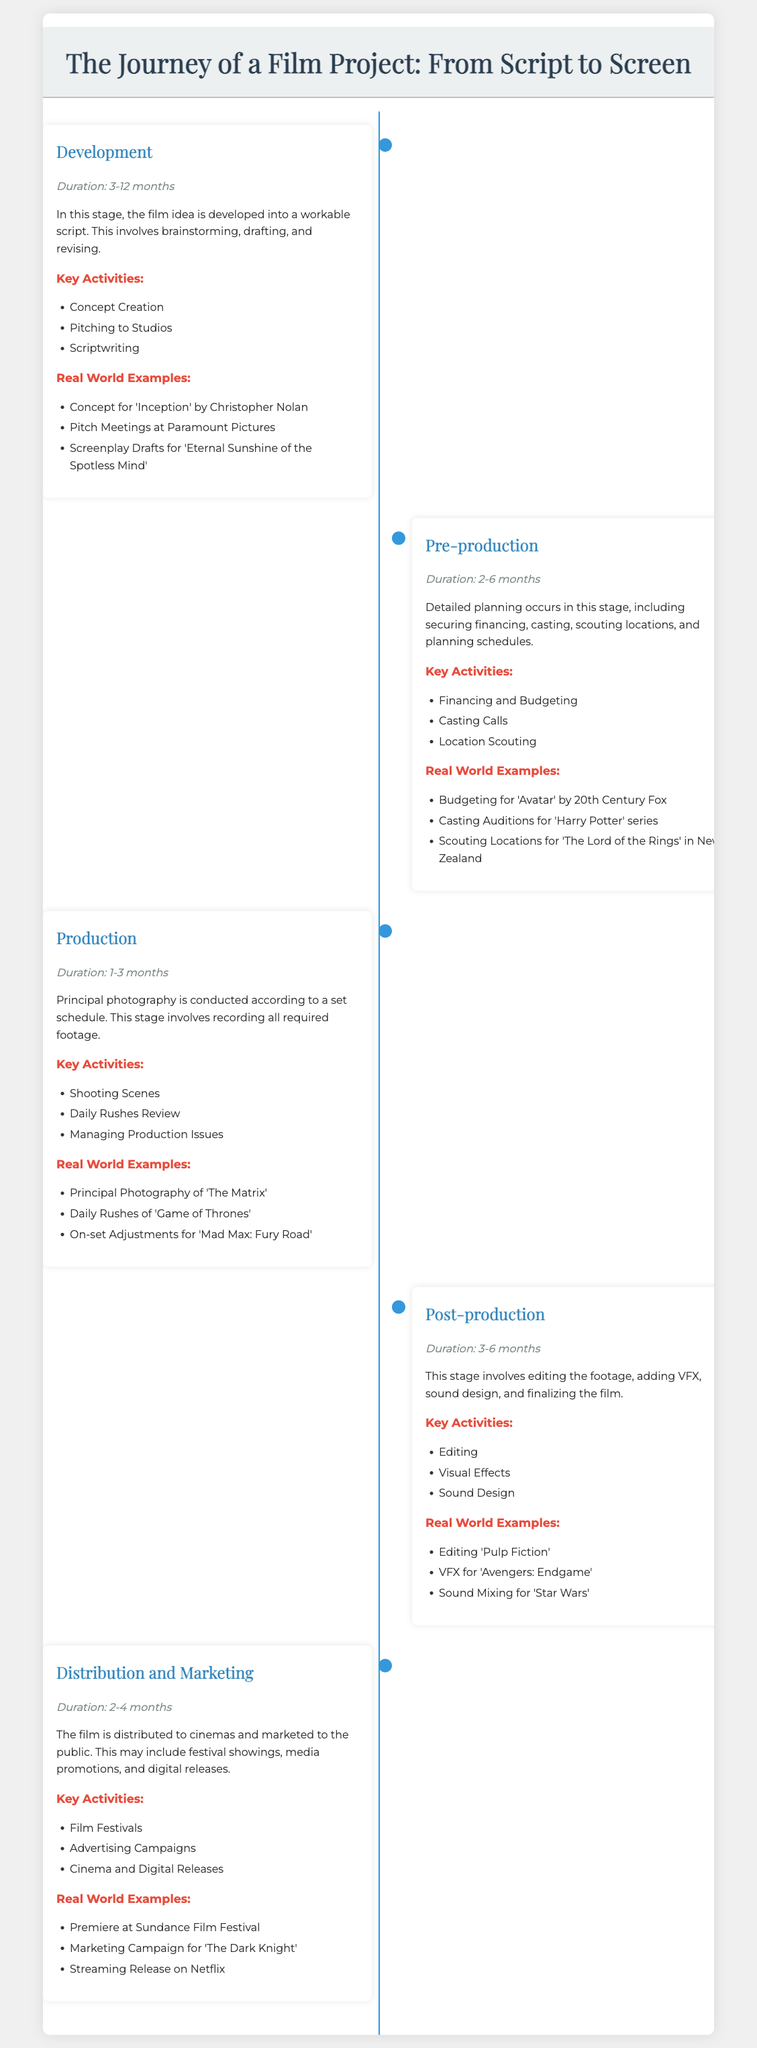What is the duration of the Development stage? The duration of the Development stage is specified in the document as 3-12 months.
Answer: 3-12 months What are the key activities in Pre-production? The document lists the key activities for Pre-production, including Financing and Budgeting, Casting Calls, and Location Scouting.
Answer: Financing and Budgeting, Casting Calls, Location Scouting Which film is mentioned as an example in the Production stage? The document provides examples of films during the Production stage, notably Principal Photography of 'The Matrix'.
Answer: The Matrix How long does the Post-production stage typically last? The document indicates that the duration of the Post-production stage is 3-6 months.
Answer: 3-6 months What is the purpose of the Distribution and Marketing stage? The document states that this stage involves distributing the film to cinemas and marketing to the public, including festival showings and media promotions.
Answer: Distributing to cinemas and marketing to the public Which film festival is mentioned in the Distribution and Marketing stage? The document suggests that the premiere is at the Sundance Film Festival during the Distribution and Marketing stage.
Answer: Sundance Film Festival What is the function of the timeline's vertical line? The vertical line in the timeline visually separates and connects the stages of film production listed in the infographic.
Answer: Connects the stages How many stages are there in total on the timeline? The timeline infographic outlines five distinct stages in the film project journey.
Answer: Five What is the key activity in the Development stage? The document lists Concept Creation, Pitching to Studios, and Scriptwriting as key activities during the Development stage.
Answer: Concept Creation, Pitching to Studios, Scriptwriting What film is referenced for VFX in the Post-production stage? ‘Avengers: Endgame' is cited in the document as an example for VFX during the Post-production stage.
Answer: Avengers: Endgame 